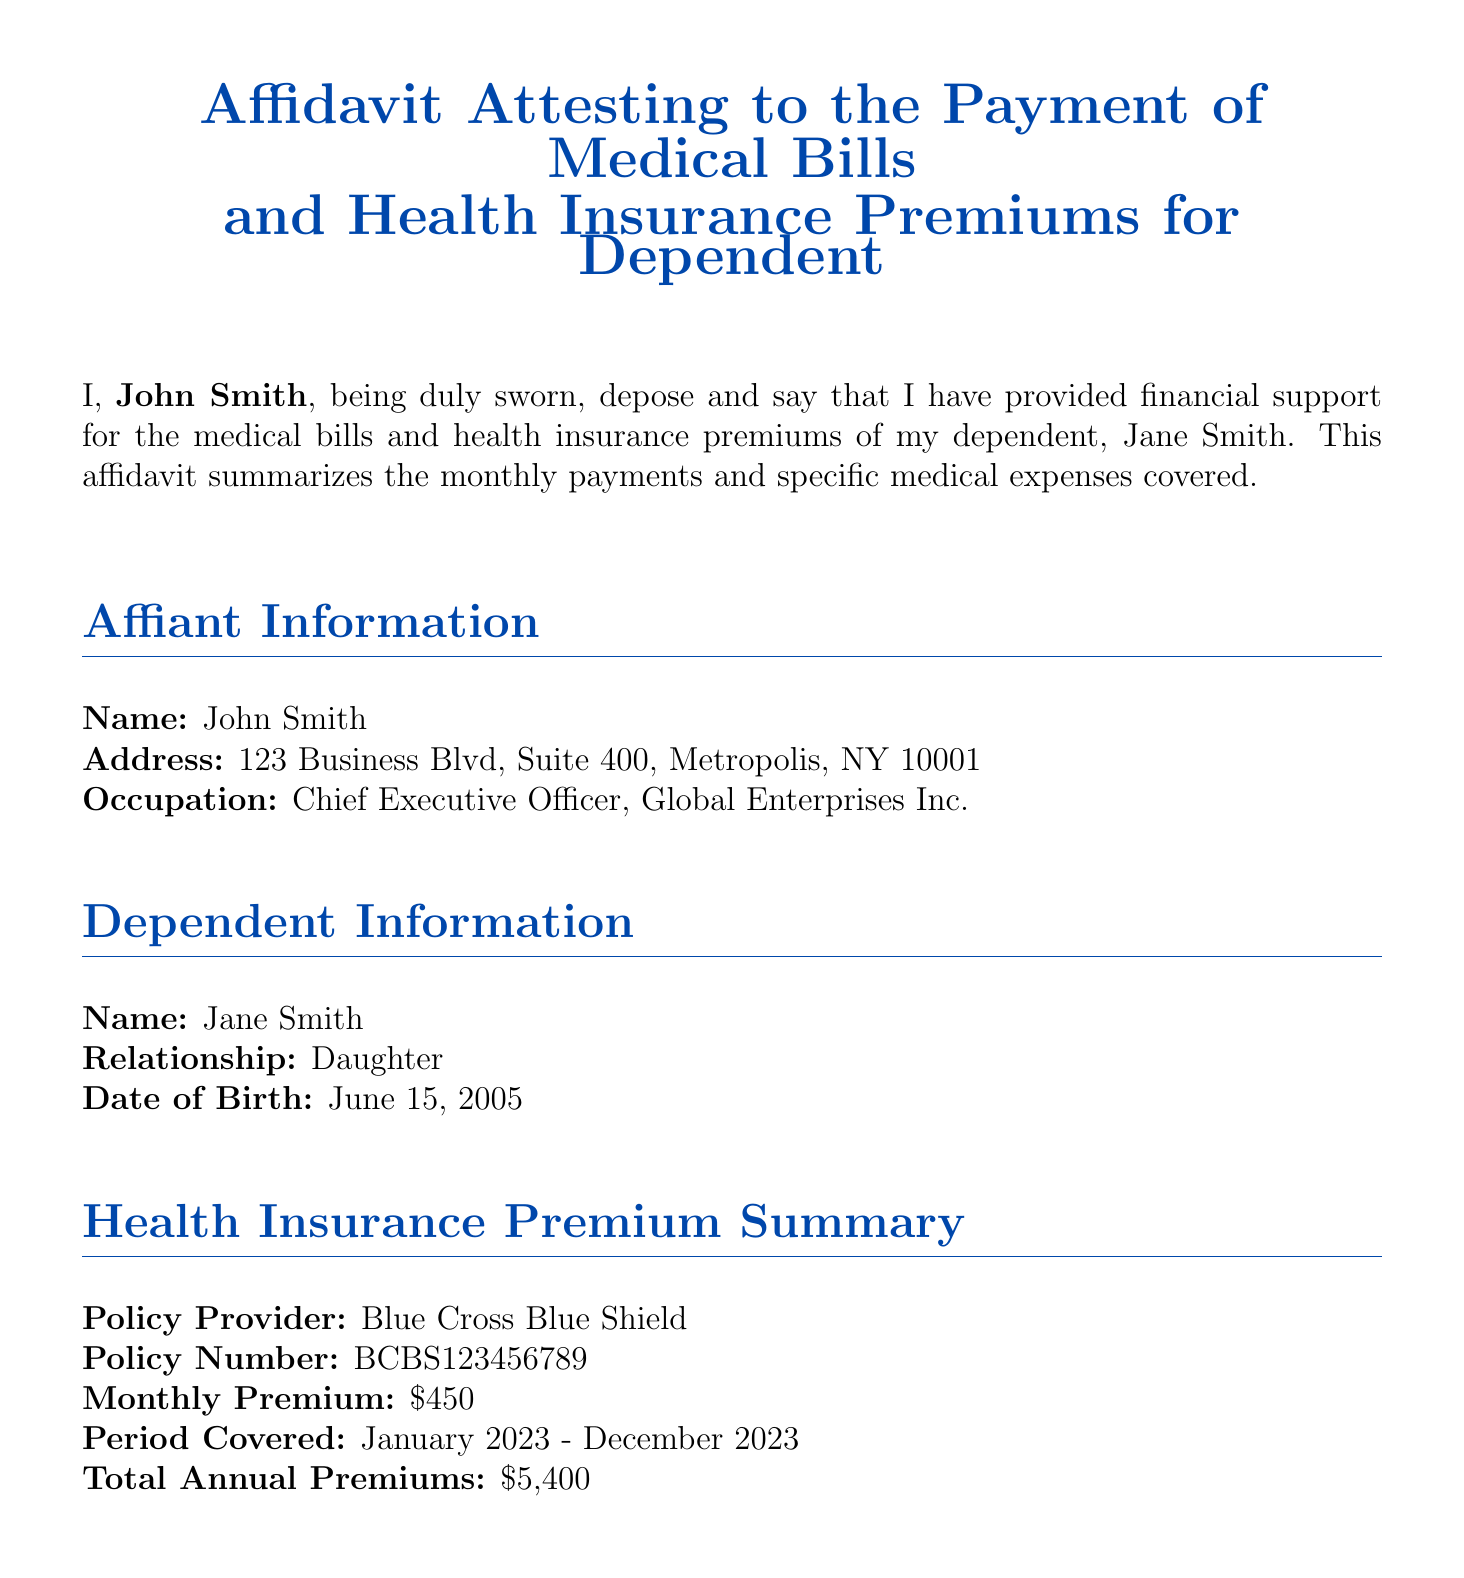What is the name of the affiant? The affiant's name is mentioned at the beginning of the affidavit as John Smith.
Answer: John Smith What is the monthly premium for the health insurance? The document specifies the monthly premium as listed under the health insurance premium summary.
Answer: $450 For what period is the health insurance covered? The document states the period covered for the health insurance premiums from January 2023 to December 2023.
Answer: January 2023 - December 2023 What is the total amount of medical bill payments in July? The specific monthly payments are summarized in a table, which lists the medical bill payment for July as $500.
Answer: $500 Which specific medical expense occurred on May 18, 2023? The document lists specific medical expenses covered, identifying the orthodontic consultation on that date.
Answer: Orthodontic Consultation at Align Life Orthodontics How much was paid in medical bills in April? April's medical bill payment is provided in the monthly payments summary table, which states the amount.
Answer: $400 What was the reason for the medical expense on January 10, 2023? The specific medical expense list describes this date as a pediatric checkup.
Answer: Pediatric Checkup at Metropolis Pediatrics Who is the dependent mentioned in the affidavit? The dependent's information is located in the dependent information section, stating the name and relationship.
Answer: Jane Smith What is the total annual premium for the health insurance? The total annual premiums sum is calculated based on the monthly premium provided over the period covered.
Answer: $5,400 